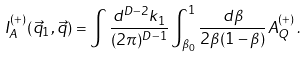Convert formula to latex. <formula><loc_0><loc_0><loc_500><loc_500>I _ { A } ^ { ( + ) } ( \vec { q } _ { 1 } , \vec { q } ) = \int \frac { d ^ { D - 2 } k _ { 1 } } { ( 2 \pi ) ^ { D - 1 } } \int _ { \beta _ { 0 } } ^ { 1 } \frac { d \beta } { 2 \beta ( 1 - \beta ) } A _ { Q } ^ { ( + ) } \, .</formula> 